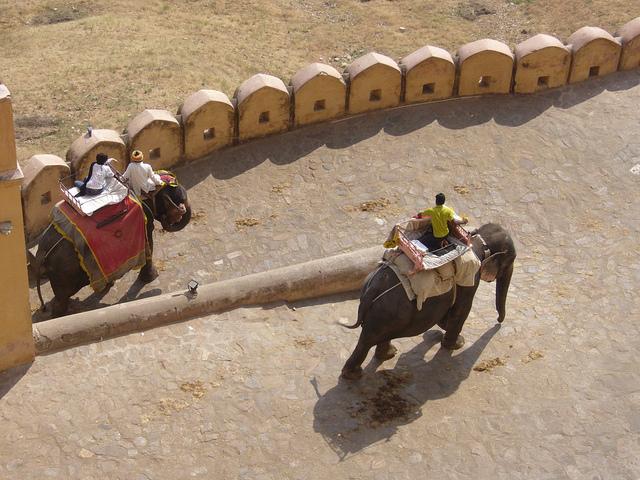What are the men sitting on atop the elephants?
Be succinct. Seats. Is this photo taken from the ground?
Write a very short answer. No. What kind of elephants are these?
Keep it brief. Asian. 